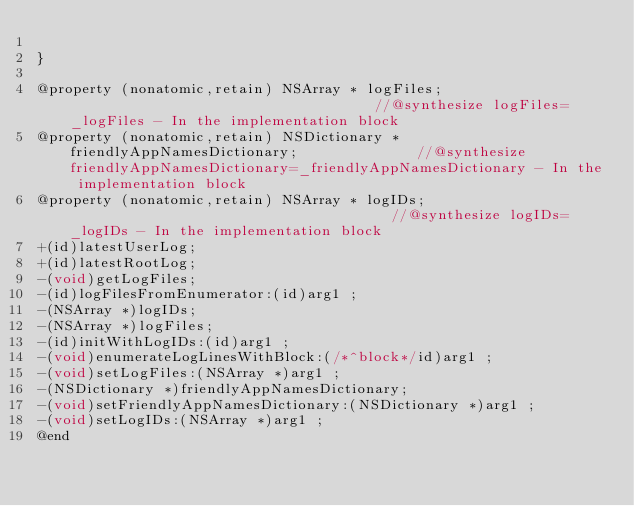<code> <loc_0><loc_0><loc_500><loc_500><_C_>
}

@property (nonatomic,retain) NSArray * logFiles;                                     //@synthesize logFiles=_logFiles - In the implementation block
@property (nonatomic,retain) NSDictionary * friendlyAppNamesDictionary;              //@synthesize friendlyAppNamesDictionary=_friendlyAppNamesDictionary - In the implementation block
@property (nonatomic,retain) NSArray * logIDs;                                       //@synthesize logIDs=_logIDs - In the implementation block
+(id)latestUserLog;
+(id)latestRootLog;
-(void)getLogFiles;
-(id)logFilesFromEnumerator:(id)arg1 ;
-(NSArray *)logIDs;
-(NSArray *)logFiles;
-(id)initWithLogIDs:(id)arg1 ;
-(void)enumerateLogLinesWithBlock:(/*^block*/id)arg1 ;
-(void)setLogFiles:(NSArray *)arg1 ;
-(NSDictionary *)friendlyAppNamesDictionary;
-(void)setFriendlyAppNamesDictionary:(NSDictionary *)arg1 ;
-(void)setLogIDs:(NSArray *)arg1 ;
@end

</code> 